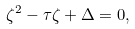<formula> <loc_0><loc_0><loc_500><loc_500>\zeta ^ { 2 } - \tau \zeta + \Delta = 0 ,</formula> 